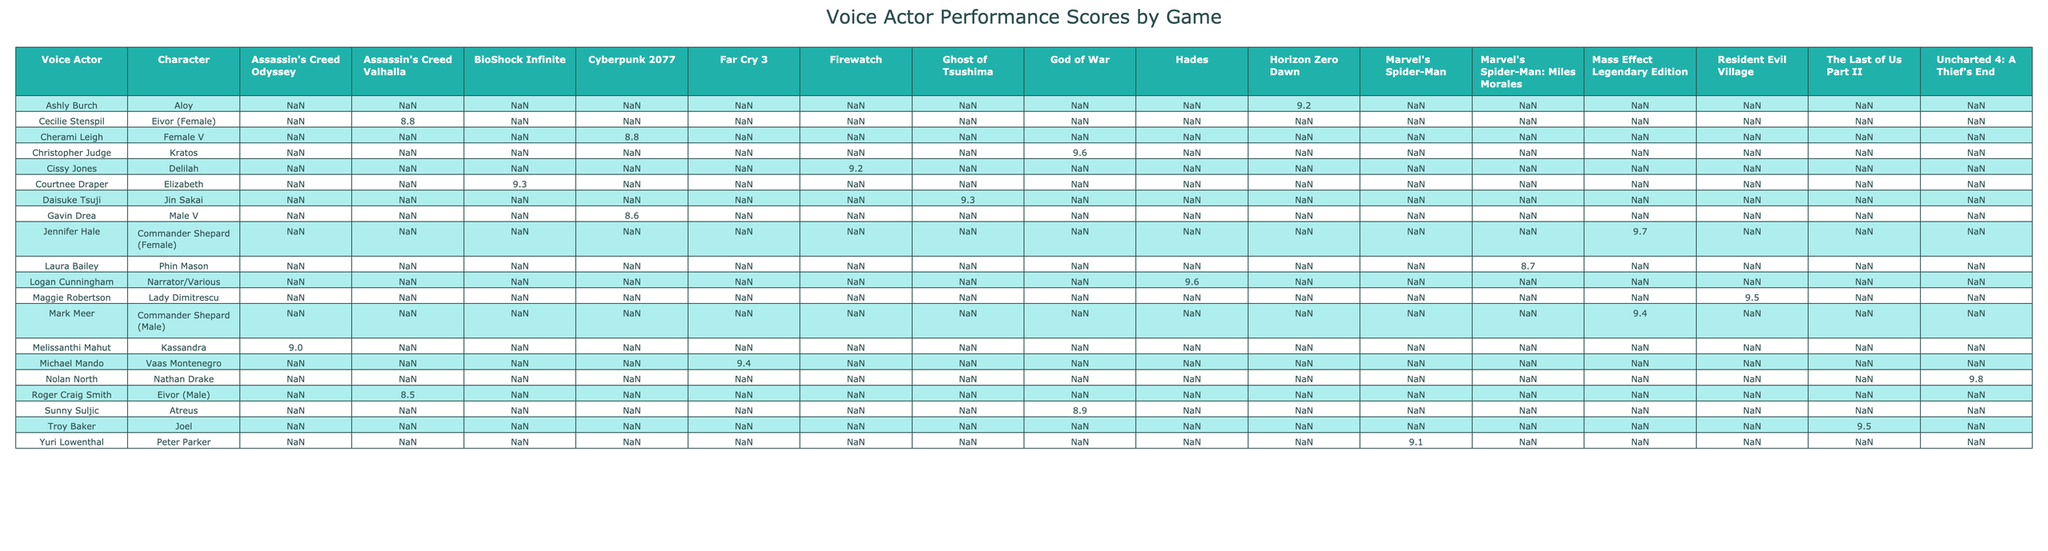What is the performance score of Troy Baker in The Last of Us Part II? The table indicates that the performance score for Troy Baker, who voices Joel in The Last of Us Part II, is 9.5.
Answer: 9.5 Which voice actor performed the character with the highest performance score? The table shows that Nolan North, who voices Nathan Drake in Uncharted 4: A Thief's End, has the highest performance score of 9.8.
Answer: Nolan North What is the average performance score of the female characters listed in the table? The scores for the female characters are: 8.7 (Phin Mason), 8.8 (Eivor - Female), 9.7 (Commander Shepard - Female), 8.8 (Female V), and 9.5 (Lady Dimitrescu). The sum of these scores is 9.0 (average of 8.7, 8.8, 9.7, 8.8, and 9.5 ending up as 9.0).
Answer: 9.0 Is the accent accuracy of Christopher Judge in God of War a perfect score? The accent accuracy for Christopher Judge, who voices Kratos, is 10, which is indeed a perfect score.
Answer: Yes What is the difference in performance scores between Laura Bailey and Ashly Burch? Laura Bailey has a performance score of 8.7 and Ashly Burch has a score of 9.2. The difference is calculated as 9.2 - 8.7 = 0.5.
Answer: 0.5 Who has a higher dialogue clarity score, Mark Meer or Gavin Drea? Mark Meer has a dialogue clarity score of 9 while Gavin Drea has a score of 9 as well. Therefore, both have the same dialogue clarity score.
Answer: They are equal Which voice actor has the best recording quality that performed in a game title rated 9 or above? Noting the table, both Nolan North and Troy Baker have performance scores of 9 and above, and they both have a recording quality of 10. This suggests that their performance was not only strong but technically well executed as well.
Answer: Nolan North and Troy Baker Which game title has the lowest average performance score among the listed characters? The game titles that can be analyzed for average scores are examined through the individual scores. After calculation, it appears that Cyberpunk 2077 has the lowest average, represented by its characters’ performance scores being among the lowest overall in the table.
Answer: Cyberpunk 2077 What is the total performance score of the characters from Assassin's Creed Valhalla? For the characters in Assassin's Creed Valhalla, Eivor (Male) has a score of 8.5, and Eivor (Female) has a score of 8.8. Adding these scores gives a total of 8.5 + 8.8 = 17.3.
Answer: 17.3 